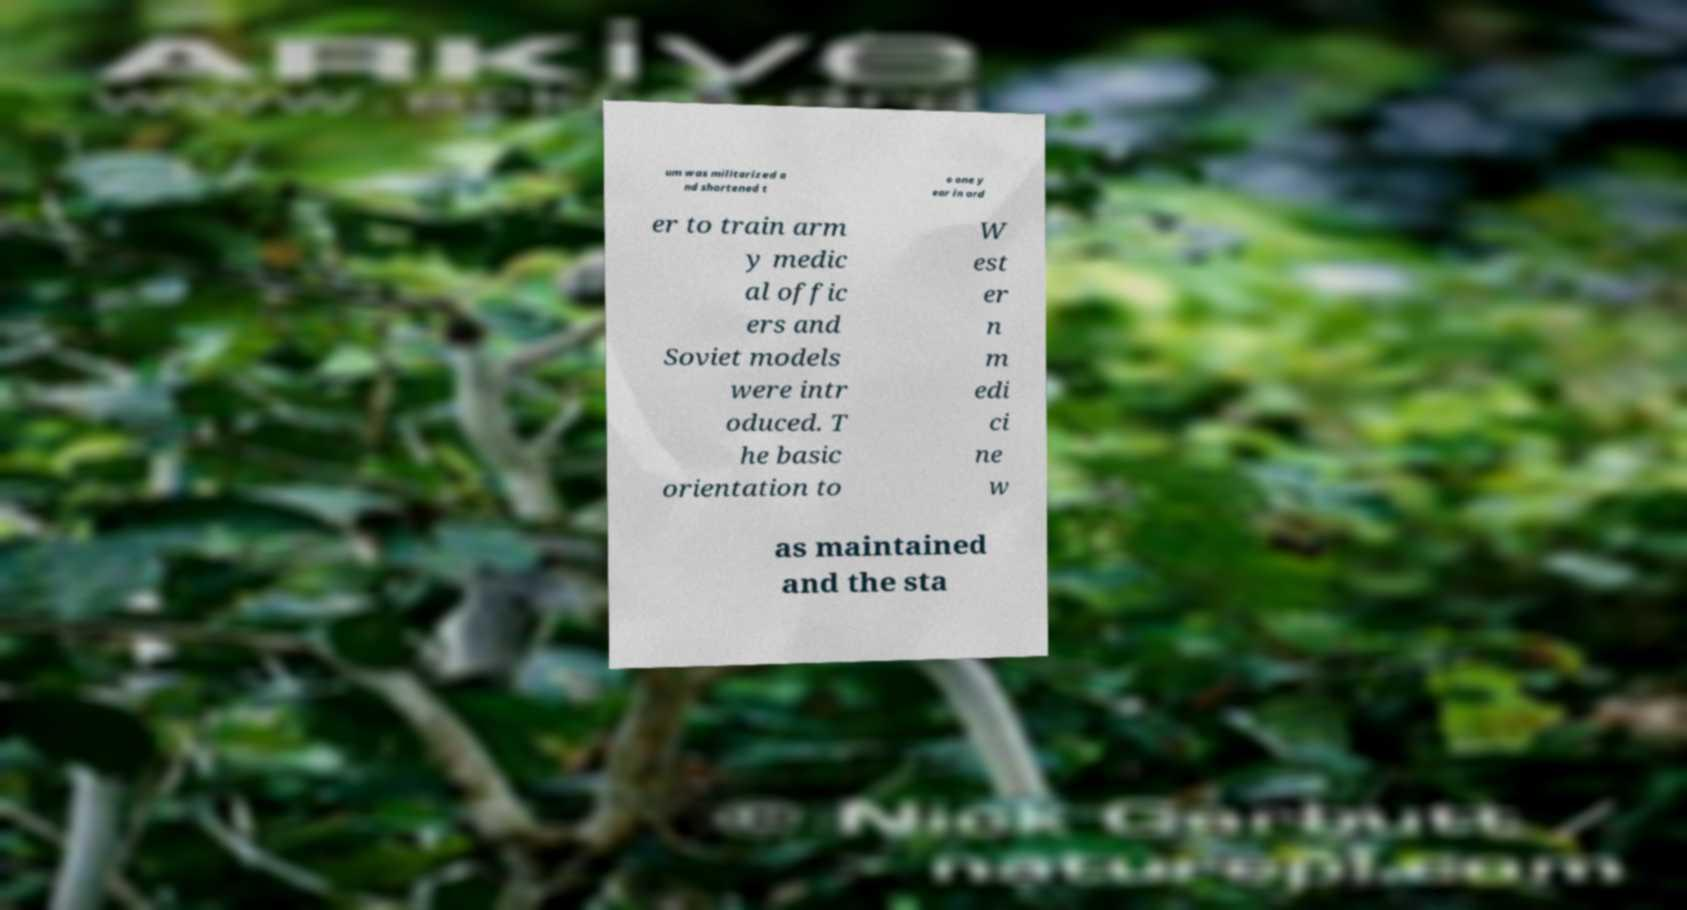Could you extract and type out the text from this image? um was militarized a nd shortened t o one y ear in ord er to train arm y medic al offic ers and Soviet models were intr oduced. T he basic orientation to W est er n m edi ci ne w as maintained and the sta 